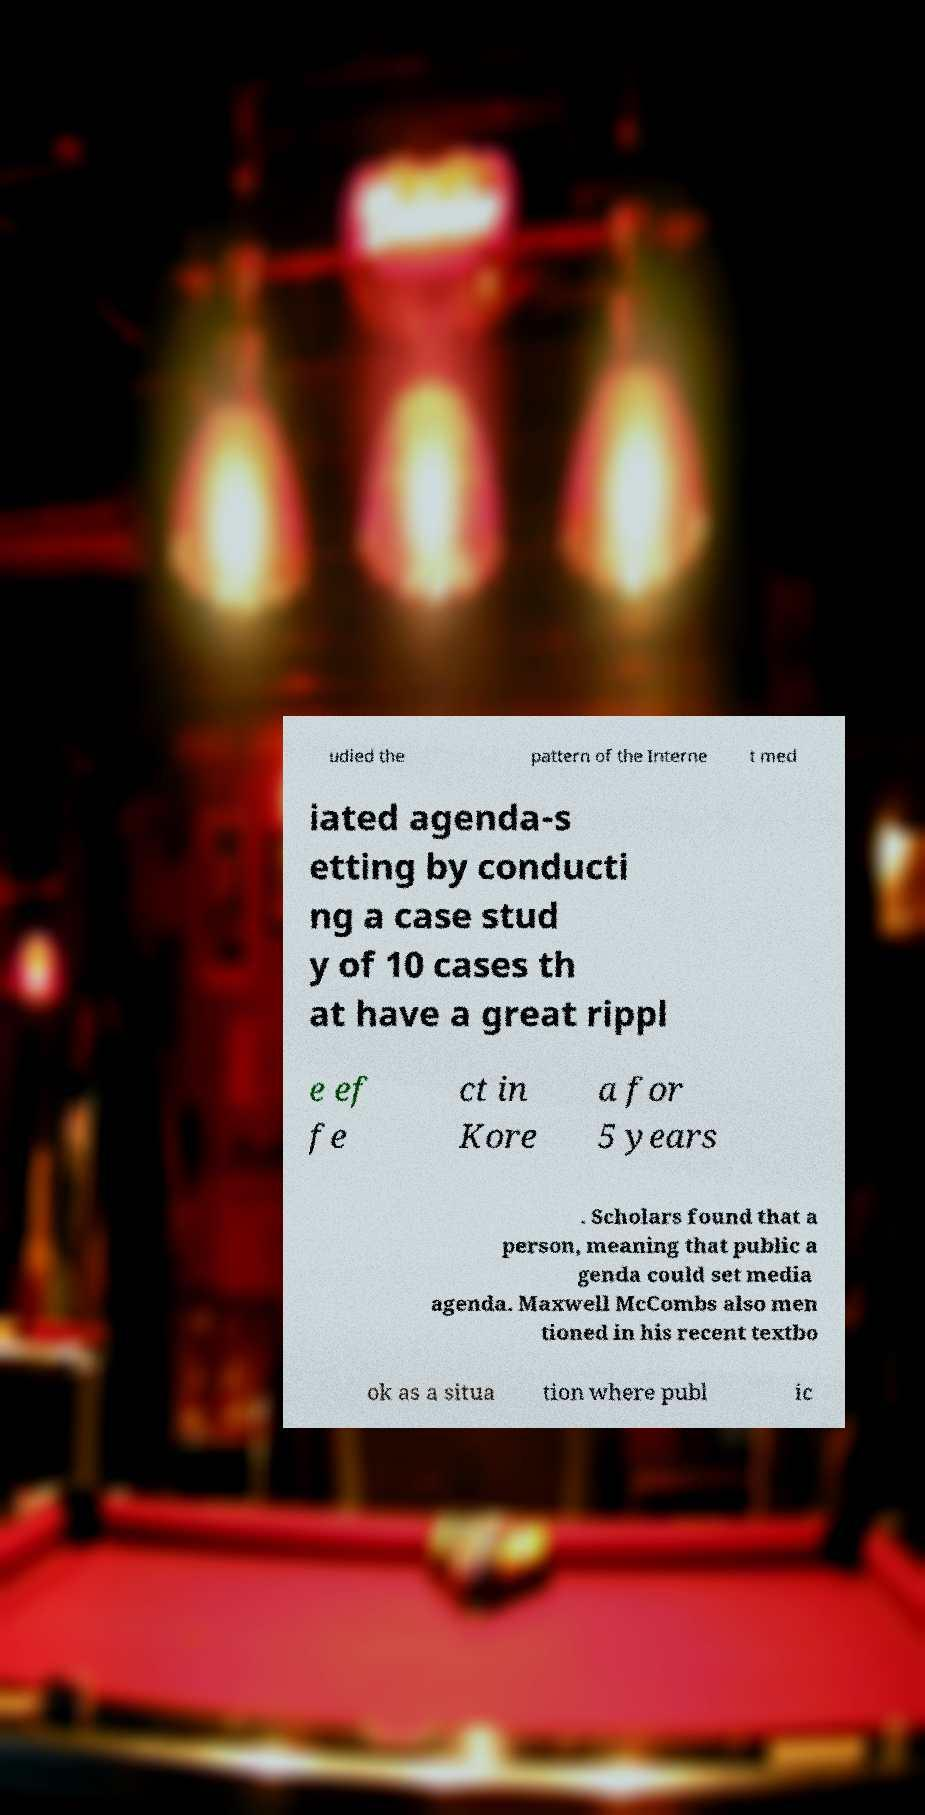Could you assist in decoding the text presented in this image and type it out clearly? udied the pattern of the Interne t med iated agenda-s etting by conducti ng a case stud y of 10 cases th at have a great rippl e ef fe ct in Kore a for 5 years . Scholars found that a person, meaning that public a genda could set media agenda. Maxwell McCombs also men tioned in his recent textbo ok as a situa tion where publ ic 